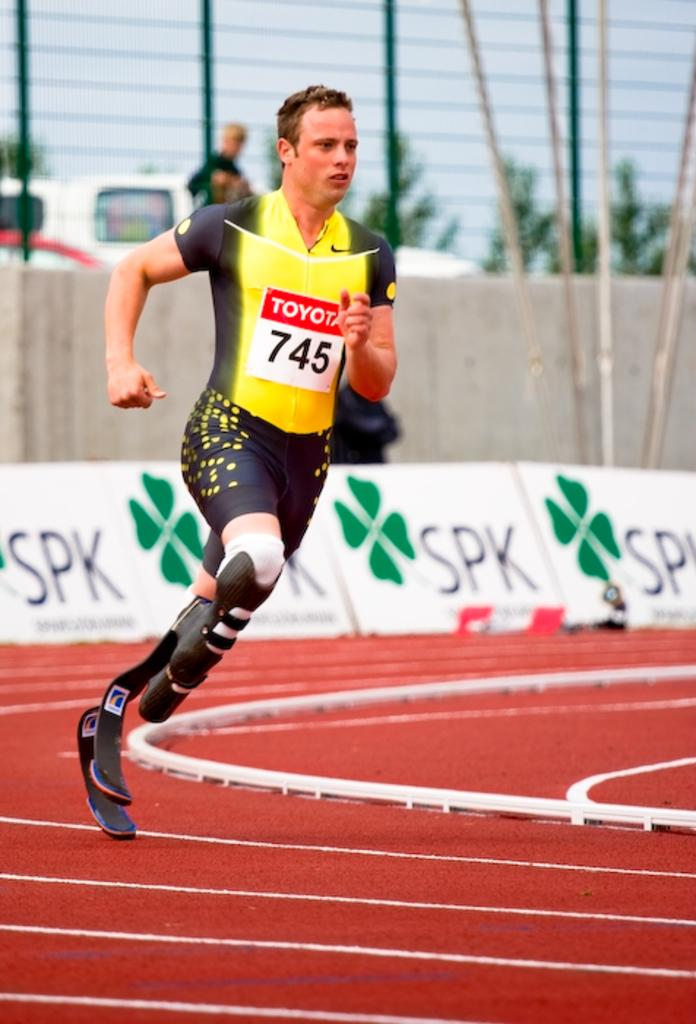What is the main subject of the image? There is a man in the image. What is the man doing in the image? The man is running. Can you describe any specific characteristics of the man? The man is handicapped. What is visible at the bottom of the image? There is a ground at the bottom of the image. What can be seen in the background of the image? There is fencing and banners in the background of the image. What type of teeth can be seen in the image? There are no teeth visible in the image. What instrument is the man playing in the image? The man is running, not playing an instrument, so there is no instrument present in the image. 